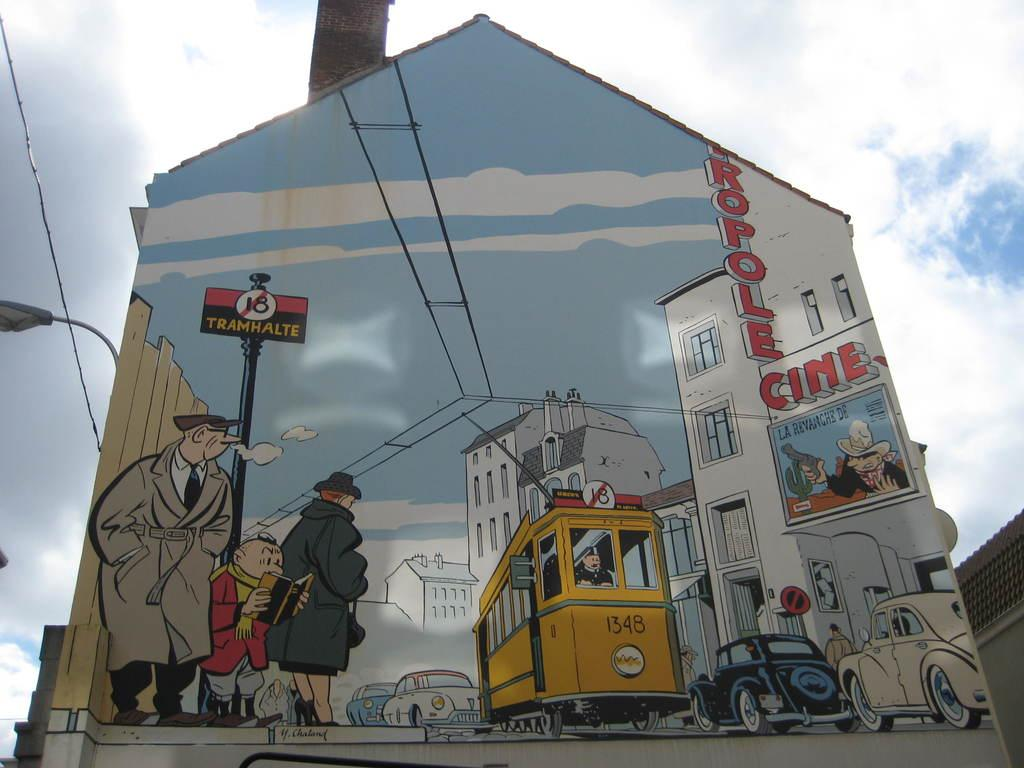What is on the wall in the image? There is a painting on the wall. What does the painting depict? The painting depicts people, buildings, and vehicles. Are there any other elements in the painting? Yes, the painting includes wires. What type of grain is being harvested by the daughter in the painting? There is no daughter present in the painting, nor is there any grain being harvested. 